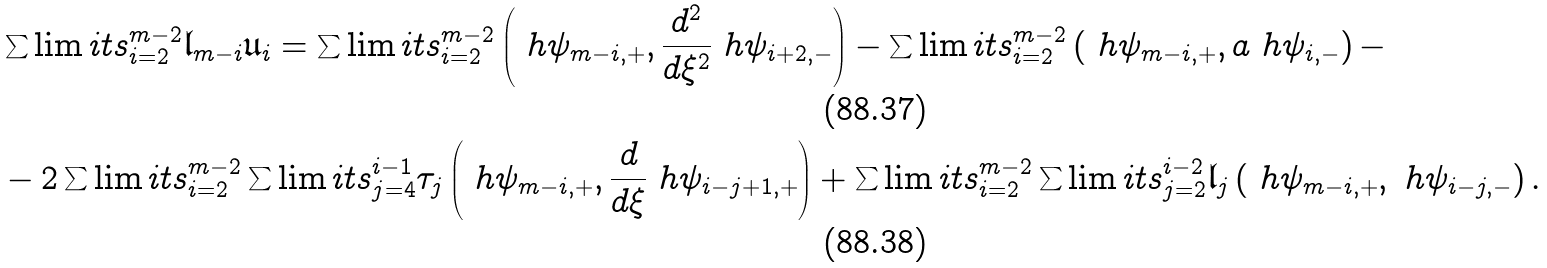<formula> <loc_0><loc_0><loc_500><loc_500>& \sum \lim i t s _ { i = 2 } ^ { m - 2 } \mathfrak { l } _ { m - i } \mathfrak { u } _ { i } = \sum \lim i t s _ { i = 2 } ^ { m - 2 } \left ( \ h \psi _ { m - i , + } , \frac { d ^ { 2 } } { d \xi ^ { 2 } } \ h \psi _ { i + 2 , - } \right ) - \sum \lim i t s _ { i = 2 } ^ { m - 2 } \left ( \ h \psi _ { m - i , + } , a \ h \psi _ { i , - } \right ) - \\ & - 2 \sum \lim i t s _ { i = 2 } ^ { m - 2 } \sum \lim i t s _ { j = 4 } ^ { i - 1 } \tau _ { j } \left ( \ h \psi _ { m - i , + } , \frac { d } { d \xi } \ h \psi _ { i - j + 1 , + } \right ) + \sum \lim i t s _ { i = 2 } ^ { m - 2 } \sum \lim i t s _ { j = 2 } ^ { i - 2 } \mathfrak { l } _ { j } \left ( \ h \psi _ { m - i , + } , \ h \psi _ { i - j , - } \right ) .</formula> 